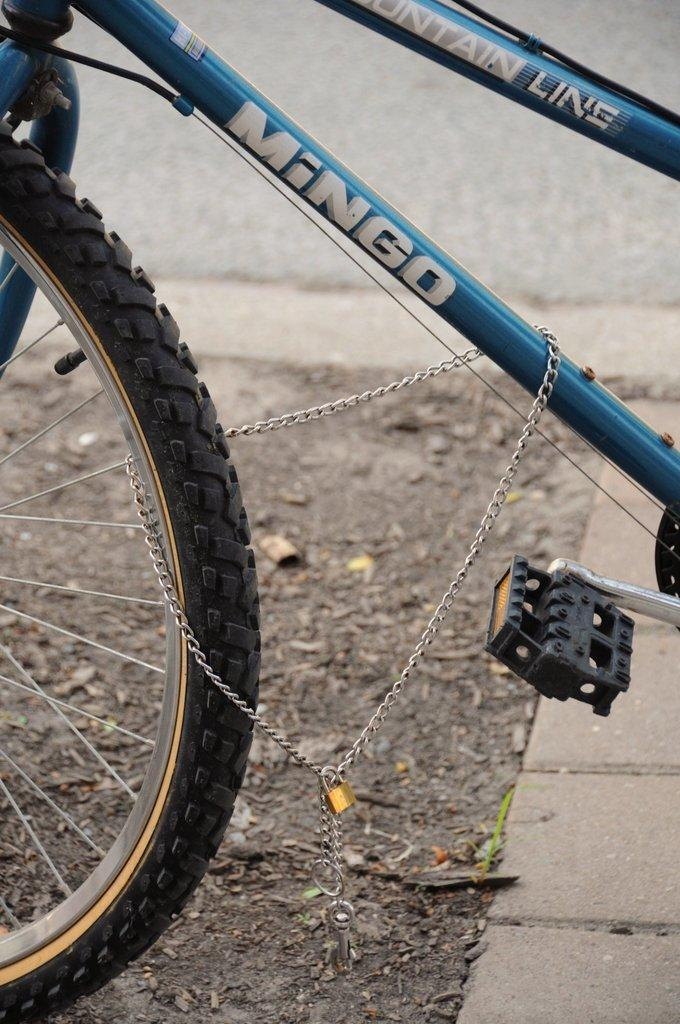What is the main object in the image? There is a cycle in the image. Where is the cycle located? The cycle is on the road. What type of bait is being used to catch fish in the image? There is no bait or fishing activity present in the image; it features a cycle on the road. What language is the person riding the cycle speaking in the image? There is no person or speech present in the image; it only shows a cycle on the road. 